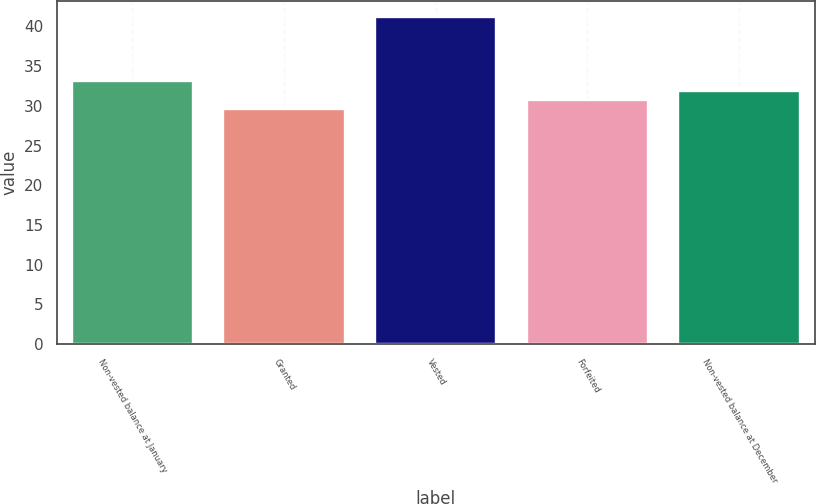Convert chart. <chart><loc_0><loc_0><loc_500><loc_500><bar_chart><fcel>Non-vested balance at January<fcel>Granted<fcel>Vested<fcel>Forfeited<fcel>Non-vested balance at December<nl><fcel>33.14<fcel>29.6<fcel>41.16<fcel>30.76<fcel>31.92<nl></chart> 